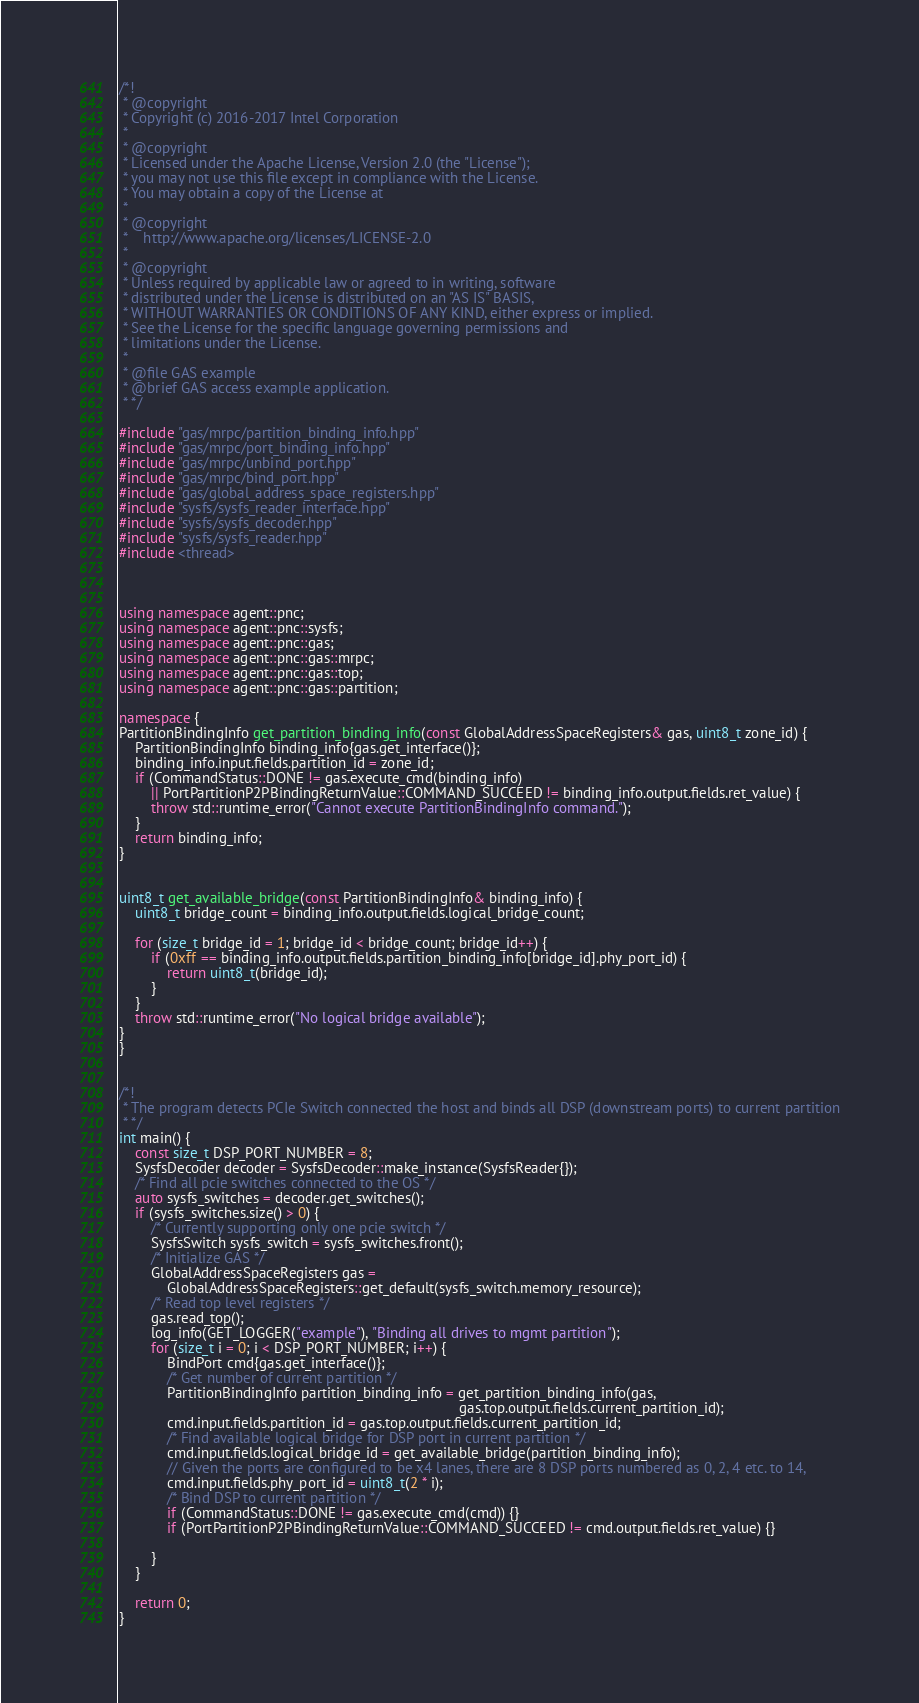Convert code to text. <code><loc_0><loc_0><loc_500><loc_500><_C++_>/*!
 * @copyright
 * Copyright (c) 2016-2017 Intel Corporation
 *
 * @copyright
 * Licensed under the Apache License, Version 2.0 (the "License");
 * you may not use this file except in compliance with the License.
 * You may obtain a copy of the License at
 *
 * @copyright
 *    http://www.apache.org/licenses/LICENSE-2.0
 *
 * @copyright
 * Unless required by applicable law or agreed to in writing, software
 * distributed under the License is distributed on an "AS IS" BASIS,
 * WITHOUT WARRANTIES OR CONDITIONS OF ANY KIND, either express or implied.
 * See the License for the specific language governing permissions and
 * limitations under the License.
 *
 * @file GAS example
 * @brief GAS access example application.
 * */

#include "gas/mrpc/partition_binding_info.hpp"
#include "gas/mrpc/port_binding_info.hpp"
#include "gas/mrpc/unbind_port.hpp"
#include "gas/mrpc/bind_port.hpp"
#include "gas/global_address_space_registers.hpp"
#include "sysfs/sysfs_reader_interface.hpp"
#include "sysfs/sysfs_decoder.hpp"
#include "sysfs/sysfs_reader.hpp"
#include <thread>



using namespace agent::pnc;
using namespace agent::pnc::sysfs;
using namespace agent::pnc::gas;
using namespace agent::pnc::gas::mrpc;
using namespace agent::pnc::gas::top;
using namespace agent::pnc::gas::partition;

namespace {
PartitionBindingInfo get_partition_binding_info(const GlobalAddressSpaceRegisters& gas, uint8_t zone_id) {
    PartitionBindingInfo binding_info{gas.get_interface()};
    binding_info.input.fields.partition_id = zone_id;
    if (CommandStatus::DONE != gas.execute_cmd(binding_info)
        || PortPartitionP2PBindingReturnValue::COMMAND_SUCCEED != binding_info.output.fields.ret_value) {
        throw std::runtime_error("Cannot execute PartitionBindingInfo command.");
    }
    return binding_info;
}


uint8_t get_available_bridge(const PartitionBindingInfo& binding_info) {
    uint8_t bridge_count = binding_info.output.fields.logical_bridge_count;

    for (size_t bridge_id = 1; bridge_id < bridge_count; bridge_id++) {
        if (0xff == binding_info.output.fields.partition_binding_info[bridge_id].phy_port_id) {
            return uint8_t(bridge_id);
        }
    }
    throw std::runtime_error("No logical bridge available");
}
}


/*!
 * The program detects PCIe Switch connected the host and binds all DSP (downstream ports) to current partition
 * */
int main() {
    const size_t DSP_PORT_NUMBER = 8;
    SysfsDecoder decoder = SysfsDecoder::make_instance(SysfsReader{});
    /* Find all pcie switches connected to the OS */
    auto sysfs_switches = decoder.get_switches();
    if (sysfs_switches.size() > 0) {
        /* Currently supporting only one pcie switch */
        SysfsSwitch sysfs_switch = sysfs_switches.front();
        /* Initialize GAS */
        GlobalAddressSpaceRegisters gas =
            GlobalAddressSpaceRegisters::get_default(sysfs_switch.memory_resource);
        /* Read top level registers */
        gas.read_top();
        log_info(GET_LOGGER("example"), "Binding all drives to mgmt partition");
        for (size_t i = 0; i < DSP_PORT_NUMBER; i++) {
            BindPort cmd{gas.get_interface()};
            /* Get number of current partition */
            PartitionBindingInfo partition_binding_info = get_partition_binding_info(gas,
                                                                                     gas.top.output.fields.current_partition_id);
            cmd.input.fields.partition_id = gas.top.output.fields.current_partition_id;
            /* Find available logical bridge for DSP port in current partition */
            cmd.input.fields.logical_bridge_id = get_available_bridge(partition_binding_info);
            // Given the ports are configured to be x4 lanes, there are 8 DSP ports numbered as 0, 2, 4 etc. to 14,
            cmd.input.fields.phy_port_id = uint8_t(2 * i);
            /* Bind DSP to current partition */
            if (CommandStatus::DONE != gas.execute_cmd(cmd)) {}
            if (PortPartitionP2PBindingReturnValue::COMMAND_SUCCEED != cmd.output.fields.ret_value) {}

        }
    }

    return 0;
}
</code> 